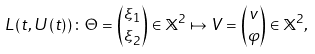Convert formula to latex. <formula><loc_0><loc_0><loc_500><loc_500>L \left ( t , U \left ( t \right ) \right ) \colon \Theta = \binom { \xi _ { 1 } } { \xi _ { 2 } } \in \mathbb { X } ^ { 2 } \mapsto V = \binom { v } { \varphi } \in \mathbb { X } ^ { 2 } ,</formula> 